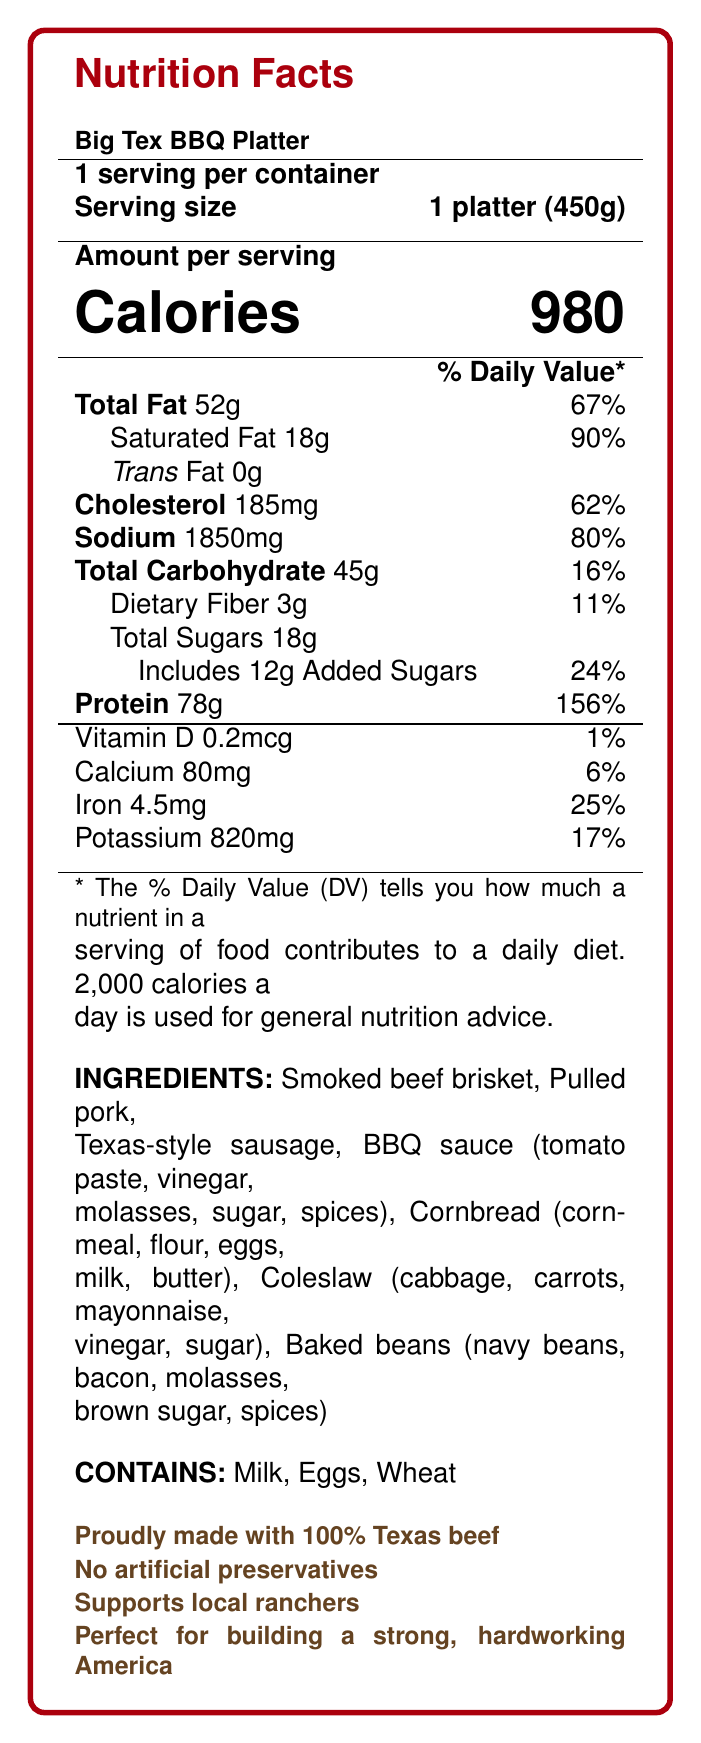what is the serving size of the Big Tex BBQ Platter? The document states that the serving size is 1 platter (450g).
Answer: 1 platter (450g) How much protein is in the Big Tex BBQ Platter? According to the document, the Big Tex BBQ Platter contains 78 grams of protein.
Answer: 78g What percentage of the daily value is the Total Fat content? The document lists that the Total Fat content is 52g, which is 67% of the daily value.
Answer: 67% How much sodium does one serving of the Big Tex BBQ Platter contain? The document specifies that one serving contains 1850 milligrams of sodium.
Answer: 1850mg What are the main ingredients in the Big Tex BBQ Platter? The ingredients listed in the document include smoked beef brisket, pulled pork, Texas-style sausage, BBQ sauce (tomato paste, vinegar, molasses, sugar, spices), cornbread (cornmeal, flour, eggs, milk, butter), coleslaw (cabbage, carrots, mayonnaise, vinegar, sugar), and baked beans (navy beans, bacon, molasses, brown sugar, spices).
Answer: Smoked beef brisket, Pulled pork, Texas-style sausage, BBQ sauce, Cornbread, Coleslaw, Baked beans Which allergens are present in the Big Tex BBQ Platter? A. Peanuts, Soy, Milk B. Milk, Eggs, Wheat C. Eggs, Wheat, Soy D. Seafood, Milk, Soy The document indicates that the Big Tex BBQ Platter contains Milk, Eggs, and Wheat.
Answer: B What is the calorie content of the Big Tex BBQ Platter? A. 450 calories B. 600 calories C. 800 calories D. 980 calories The document clearly states that the Big Tex BBQ Platter contains 980 calories.
Answer: D Does the BBQ Platter contain any artificial preservatives? The document specifies, "No artificial preservatives."
Answer: No Is the Big Tex BBQ Platter suitable for someone with a gluten allergy? The document lists wheat as one of the allergens, indicating it is not suitable for someone with a gluten allergy.
Answer: No How much dietary fiber is in the Big Tex BBQ Platter? The document specifies that the dietary fiber content is 3 grams.
Answer: 3g What is the percent daily value of iron in the Big Tex BBQ Platter? The document states that the iron content is 4.5mg, which is 25% of the daily value.
Answer: 25% Are there any vitamins in the Big Tex BBQ Platter? If so, which ones and in what quantity? The document states the presence of vitamin D in the quantity of 0.2 mcg.
Answer: Vitamin D, 0.2mcg Is the Big Tex BBQ Platter made with 100% Texas beef? The document mentions "Proudly made with 100% Texas beef."
Answer: Yes How many servings are in one container of the Big Tex BBQ Platter? The document states that there is 1 serving per container.
Answer: 1 What is the total amount of sugars, including added sugars, in the Big Tex BBQ Platter? The document mentions that the platter contains 18 grams of total sugars, including 12 grams of added sugars.
Answer: 18g total sugars, 12g added sugars Can the exact price of the Big Tex BBQ Platter be determined from the document? The document does not provide any information regarding the price of the Big Tex BBQ Platter.
Answer: Cannot be determined 